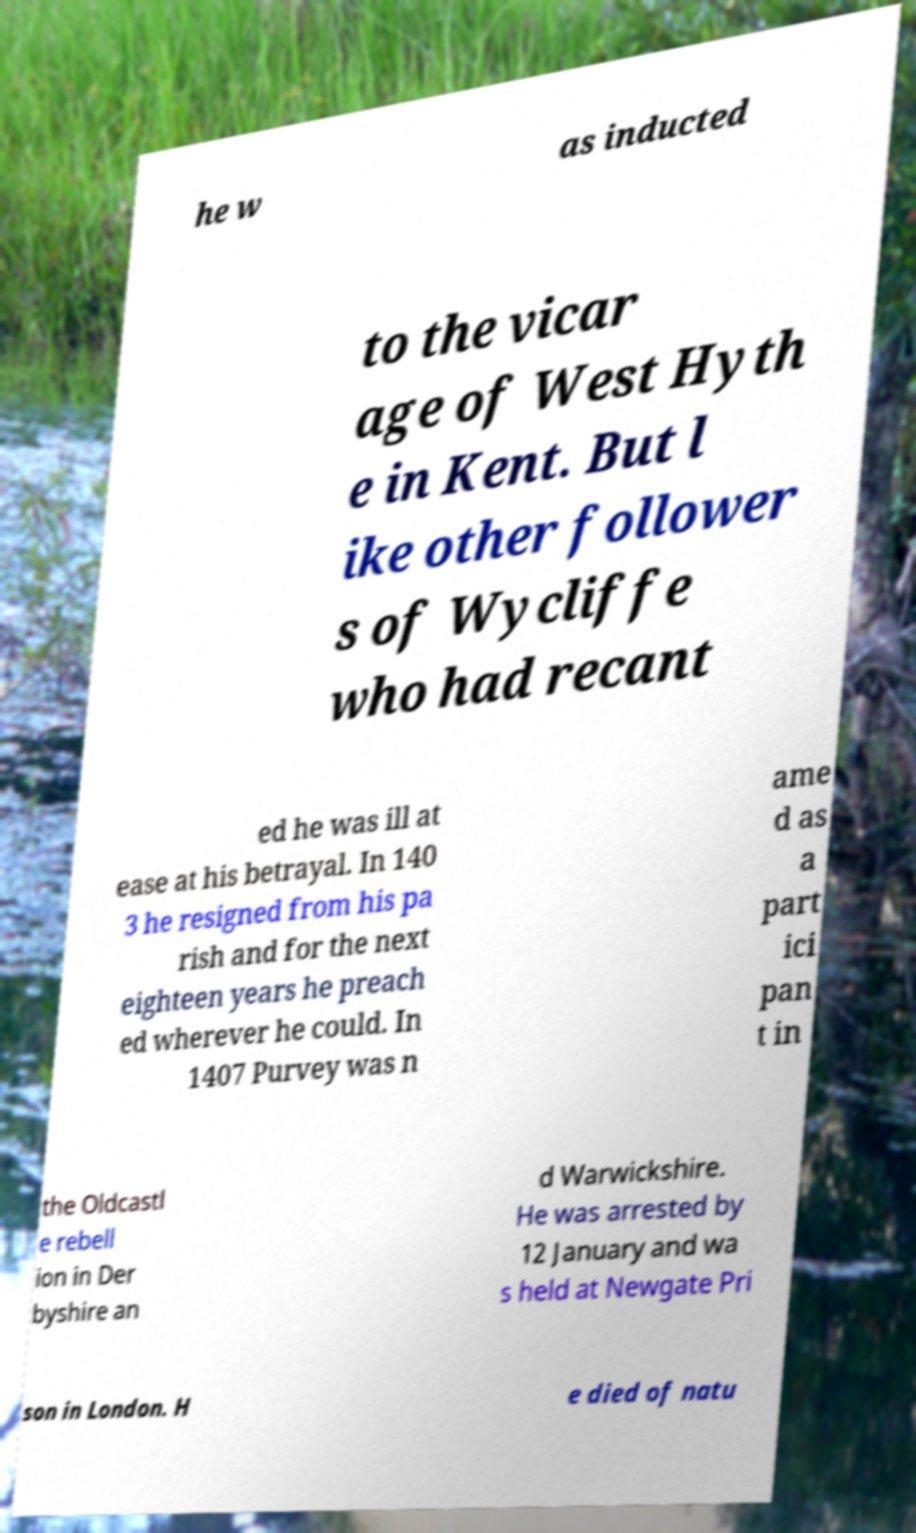I need the written content from this picture converted into text. Can you do that? he w as inducted to the vicar age of West Hyth e in Kent. But l ike other follower s of Wycliffe who had recant ed he was ill at ease at his betrayal. In 140 3 he resigned from his pa rish and for the next eighteen years he preach ed wherever he could. In 1407 Purvey was n ame d as a part ici pan t in the Oldcastl e rebell ion in Der byshire an d Warwickshire. He was arrested by 12 January and wa s held at Newgate Pri son in London. H e died of natu 